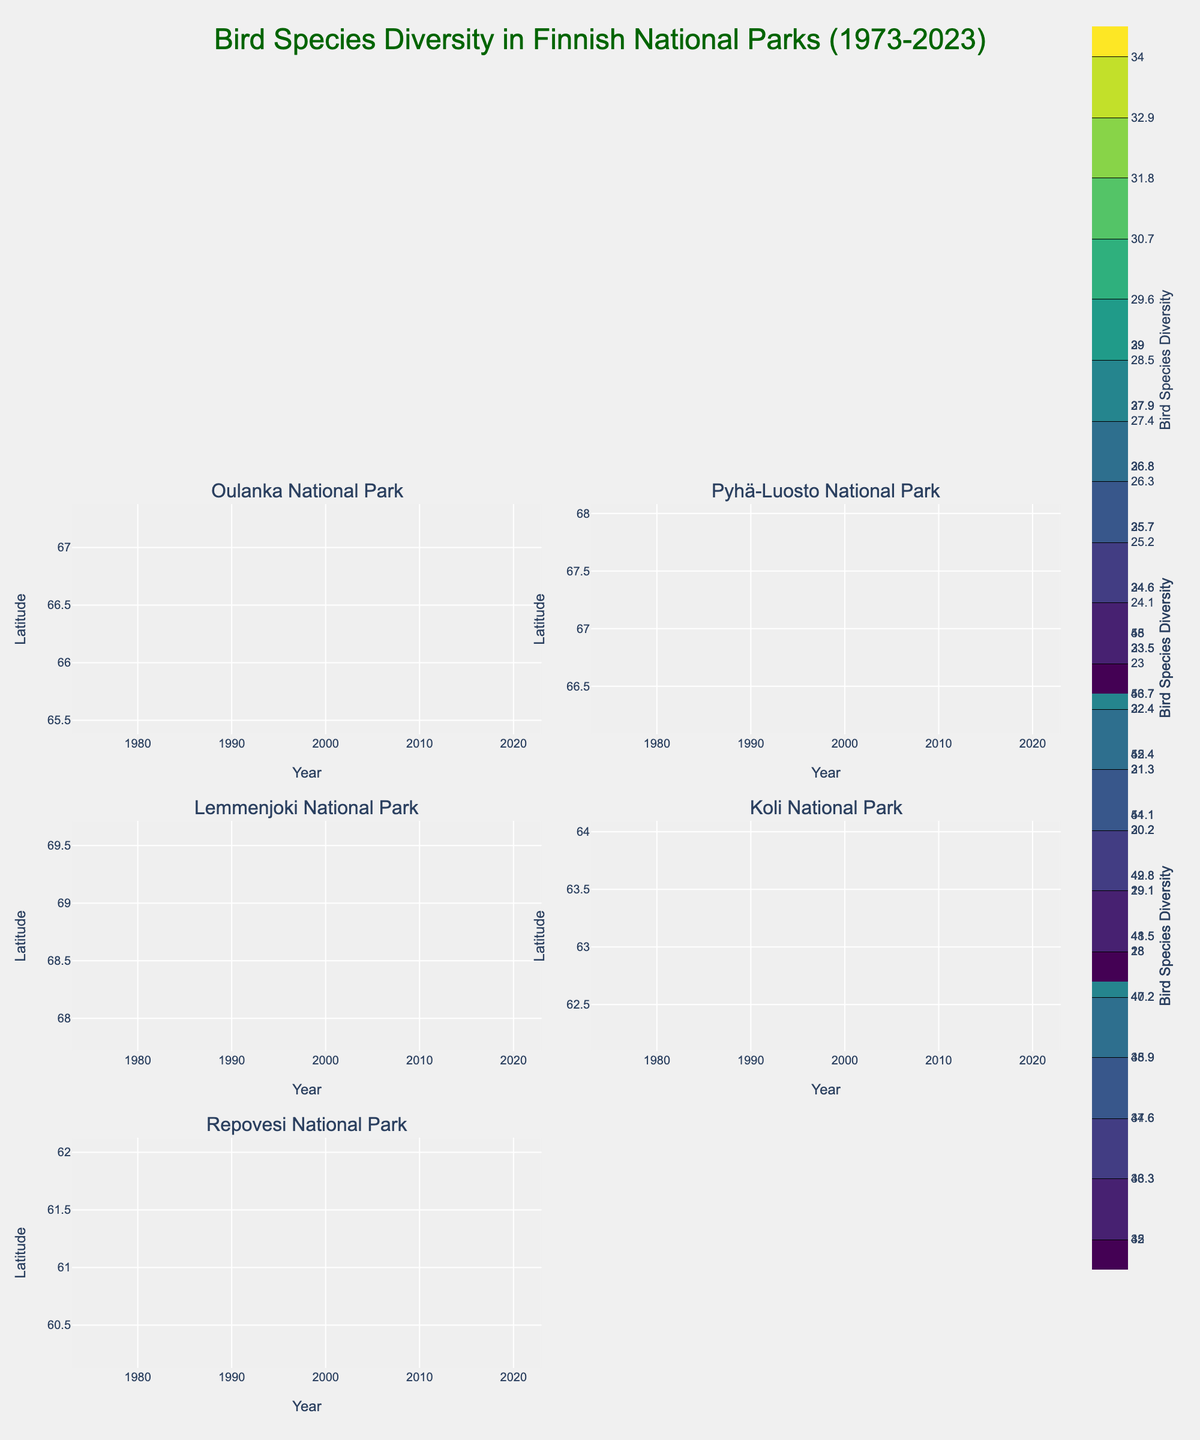What's the title of the figure? The title is at the top of the figure, describing the overall content.
Answer: Bird Species Diversity in Finnish National Parks (1973-2023) Which national park exhibits the highest bird species diversity in 2023? Look at the contour plots and the color scales; Oulanka National Park has the highest bird species diversity in 2023.
Answer: Oulanka National Park How does bird species diversity change over time in Oulanka National Park? Trace the contour lines in the subplot for Oulanka National Park from 1973 to 2023; the contour levels increase, showing an increase in bird species diversity over time.
Answer: Increases In which years does Pyhä-Luosto National Park show a similar bird species diversity to Oulanka National Park? Compare the contour levels of Pyhä-Luosto National Park and Oulanka National Park; in the years 1983 and 2003, the contour levels are similar.
Answer: 1983 and 2003 What is the general trend of bird species diversity in Lemmenjoki National Park? By examining the contour levels from 1973 to 2023 in the subplot for Lemmenjoki National Park; the contour levels consistently increase.
Answer: Increases Between Koli and Repovesi National Parks, which one shows a faster increase in bird species diversity from 1973 to 2023? Compare the spacing of contour lines in Koli and Repovesi National Parks; Koli shows more tightly packed contour lines indicating a faster increase.
Answer: Koli National Park How does the latitude affect bird species diversity in the depicted Finnish national parks? Look at the y-axis labeled "Latitude" and observe how the contours change vertically within each subplot; diversity tends to increase in national parks with lower latitudes.
Answer: Lower latitudes have higher diversity Which national park has the lowest bird species diversity in 1973 and what is the value? Look at the contour levels for each national park in 1973 and identify the minimum value; Lemmenjoki National Park has the lowest value at 20.
Answer: Lemmenjoki National Park with 20 